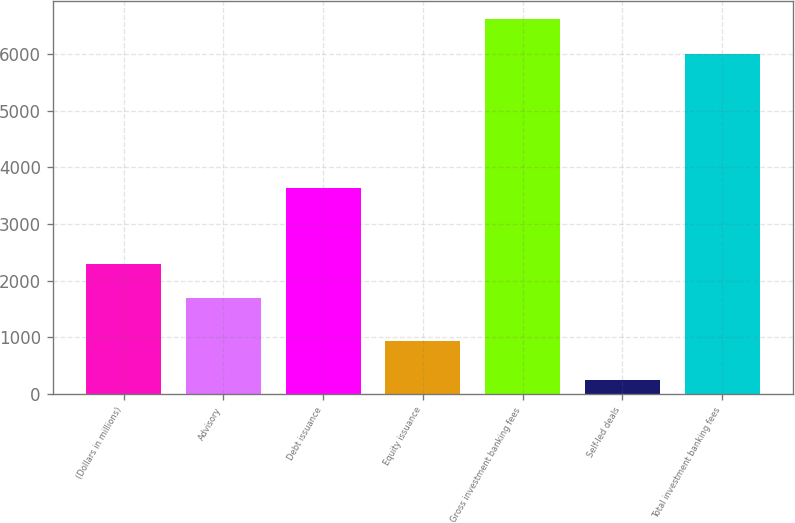<chart> <loc_0><loc_0><loc_500><loc_500><bar_chart><fcel>(Dollars in millions)<fcel>Advisory<fcel>Debt issuance<fcel>Equity issuance<fcel>Gross investment banking fees<fcel>Self-led deals<fcel>Total investment banking fees<nl><fcel>2292.1<fcel>1691<fcel>3635<fcel>940<fcel>6612.1<fcel>255<fcel>6011<nl></chart> 